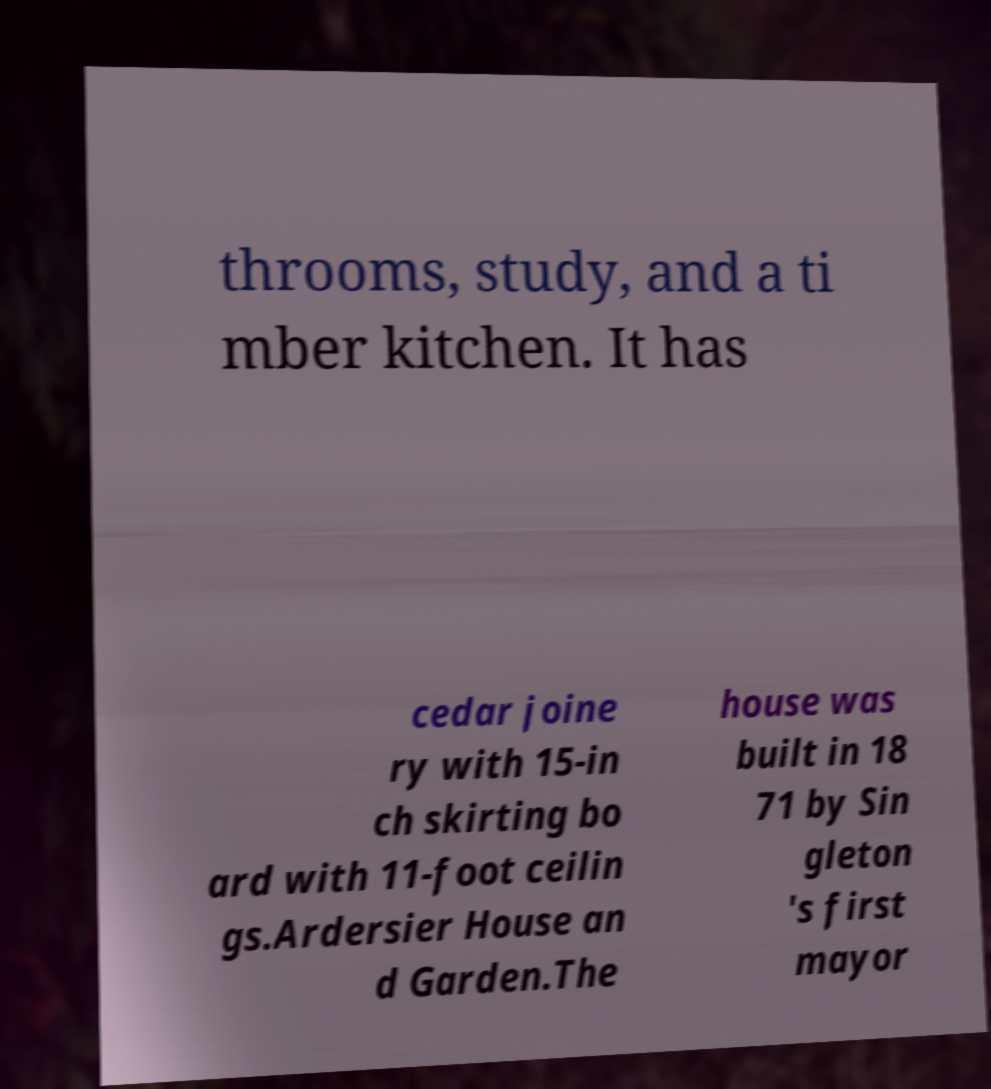What messages or text are displayed in this image? I need them in a readable, typed format. throoms, study, and a ti mber kitchen. It has cedar joine ry with 15-in ch skirting bo ard with 11-foot ceilin gs.Ardersier House an d Garden.The house was built in 18 71 by Sin gleton 's first mayor 